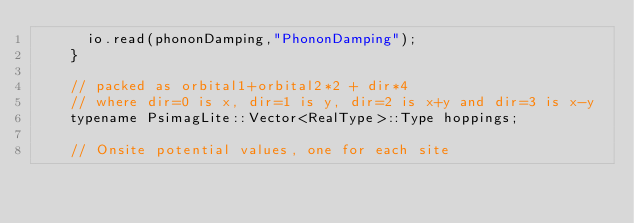<code> <loc_0><loc_0><loc_500><loc_500><_C_>			io.read(phononDamping,"PhononDamping");
		}

		// packed as orbital1+orbital2*2 + dir*4
		// where dir=0 is x, dir=1 is y, dir=2 is x+y and dir=3 is x-y
		typename PsimagLite::Vector<RealType>::Type hoppings;

		// Onsite potential values, one for each site</code> 